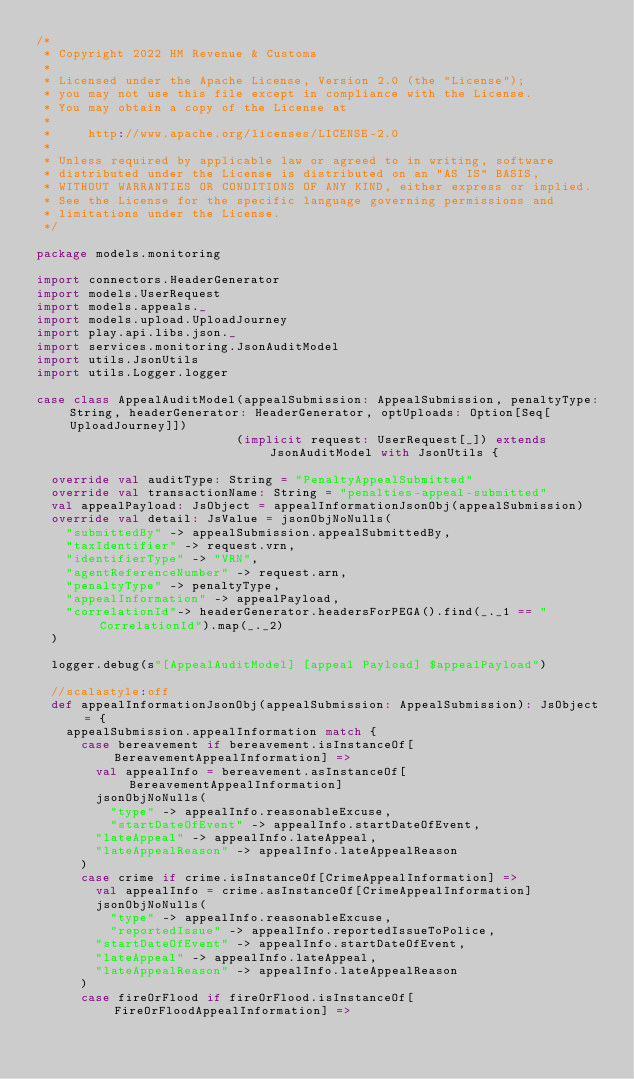Convert code to text. <code><loc_0><loc_0><loc_500><loc_500><_Scala_>/*
 * Copyright 2022 HM Revenue & Customs
 *
 * Licensed under the Apache License, Version 2.0 (the "License");
 * you may not use this file except in compliance with the License.
 * You may obtain a copy of the License at
 *
 *     http://www.apache.org/licenses/LICENSE-2.0
 *
 * Unless required by applicable law or agreed to in writing, software
 * distributed under the License is distributed on an "AS IS" BASIS,
 * WITHOUT WARRANTIES OR CONDITIONS OF ANY KIND, either express or implied.
 * See the License for the specific language governing permissions and
 * limitations under the License.
 */

package models.monitoring

import connectors.HeaderGenerator
import models.UserRequest
import models.appeals._
import models.upload.UploadJourney
import play.api.libs.json._
import services.monitoring.JsonAuditModel
import utils.JsonUtils
import utils.Logger.logger

case class AppealAuditModel(appealSubmission: AppealSubmission, penaltyType: String, headerGenerator: HeaderGenerator, optUploads: Option[Seq[UploadJourney]])
                           (implicit request: UserRequest[_]) extends JsonAuditModel with JsonUtils {

  override val auditType: String = "PenaltyAppealSubmitted"
  override val transactionName: String = "penalties-appeal-submitted"
  val appealPayload: JsObject = appealInformationJsonObj(appealSubmission)
  override val detail: JsValue = jsonObjNoNulls(
    "submittedBy" -> appealSubmission.appealSubmittedBy,
    "taxIdentifier" -> request.vrn,
    "identifierType" -> "VRN",
    "agentReferenceNumber" -> request.arn,
    "penaltyType" -> penaltyType,
    "appealInformation" -> appealPayload,
    "correlationId"-> headerGenerator.headersForPEGA().find(_._1 == "CorrelationId").map(_._2)
  )

  logger.debug(s"[AppealAuditModel] [appeal Payload] $appealPayload")

  //scalastyle:off
  def appealInformationJsonObj(appealSubmission: AppealSubmission): JsObject = {
    appealSubmission.appealInformation match {
      case bereavement if bereavement.isInstanceOf[BereavementAppealInformation] =>
        val appealInfo = bereavement.asInstanceOf[BereavementAppealInformation]
        jsonObjNoNulls(
          "type" -> appealInfo.reasonableExcuse,
          "startDateOfEvent" -> appealInfo.startDateOfEvent,
        "lateAppeal" -> appealInfo.lateAppeal,
        "lateAppealReason" -> appealInfo.lateAppealReason
      )
      case crime if crime.isInstanceOf[CrimeAppealInformation] =>
        val appealInfo = crime.asInstanceOf[CrimeAppealInformation]
        jsonObjNoNulls(
          "type" -> appealInfo.reasonableExcuse,
          "reportedIssue" -> appealInfo.reportedIssueToPolice,
        "startDateOfEvent" -> appealInfo.startDateOfEvent,
        "lateAppeal" -> appealInfo.lateAppeal,
        "lateAppealReason" -> appealInfo.lateAppealReason
      )
      case fireOrFlood if fireOrFlood.isInstanceOf[FireOrFloodAppealInformation] =></code> 